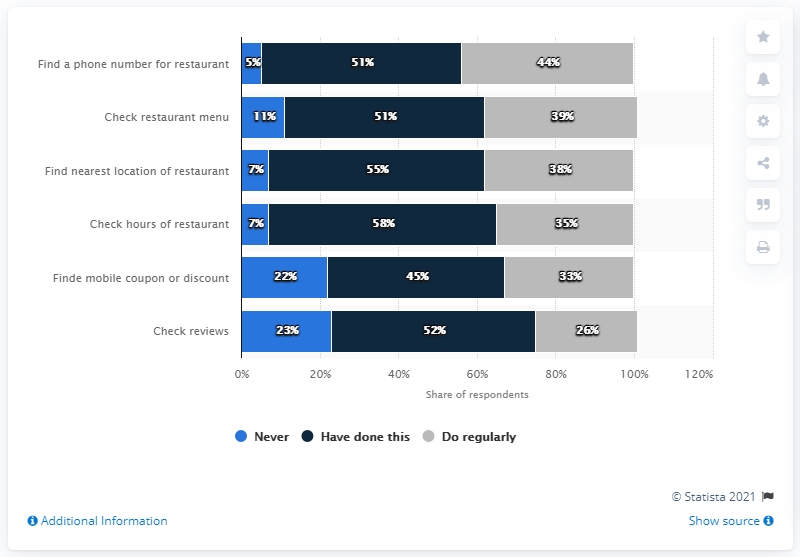Specify some key components in this picture. There is a significant difference in the number of respondents who have never checked restaurant reviews and those who have checked the hours of a restaurant for over 5 hours. It is estimated that 52 people have checked reviews. 